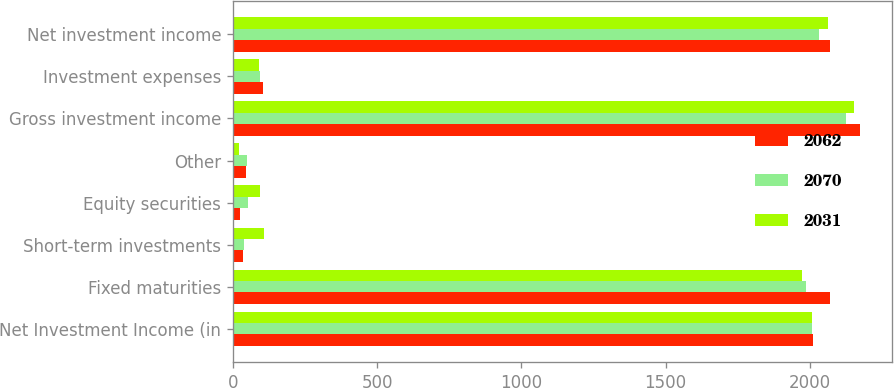Convert chart. <chart><loc_0><loc_0><loc_500><loc_500><stacked_bar_chart><ecel><fcel>Net Investment Income (in<fcel>Fixed maturities<fcel>Short-term investments<fcel>Equity securities<fcel>Other<fcel>Gross investment income<fcel>Investment expenses<fcel>Net investment income<nl><fcel>2062<fcel>2010<fcel>2071<fcel>34<fcel>26<fcel>44<fcel>2175<fcel>105<fcel>2070<nl><fcel>2070<fcel>2009<fcel>1985<fcel>38<fcel>54<fcel>48<fcel>2125<fcel>94<fcel>2031<nl><fcel>2031<fcel>2008<fcel>1972<fcel>109<fcel>93<fcel>20<fcel>2154<fcel>92<fcel>2062<nl></chart> 